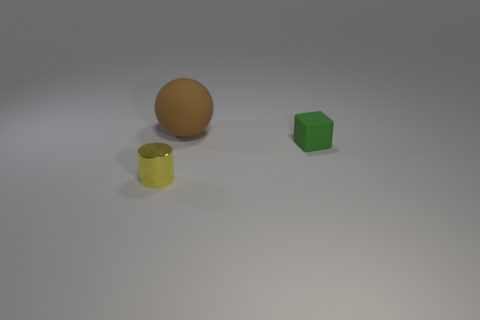Can you describe the size and shape of the objects in the image and their arrangement? Certainly! There are three objects with distinct shapes in the image. To the left side, there's a brown spherical object, which appears to be a ball. In the center, there is a yellow cylindrical object that looks like a cup or container without a handle. On the right side, we have a green hexahedral object, resembling a dice or block. They are placed roughly in a diagonal line with even spaces between them. 